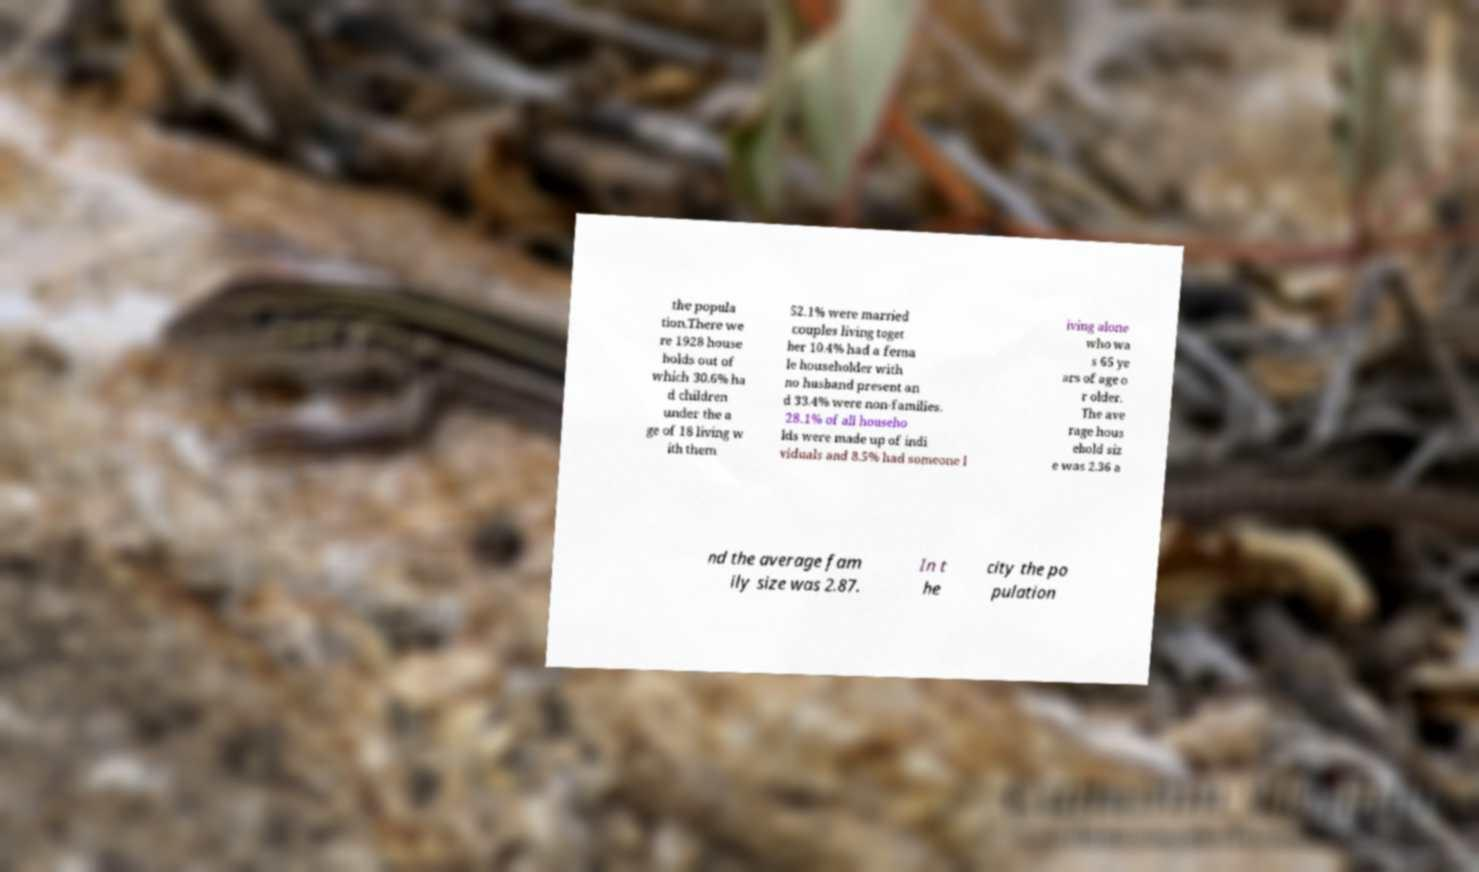What messages or text are displayed in this image? I need them in a readable, typed format. the popula tion.There we re 1928 house holds out of which 30.6% ha d children under the a ge of 18 living w ith them 52.1% were married couples living toget her 10.4% had a fema le householder with no husband present an d 33.4% were non-families. 28.1% of all househo lds were made up of indi viduals and 8.5% had someone l iving alone who wa s 65 ye ars of age o r older. The ave rage hous ehold siz e was 2.36 a nd the average fam ily size was 2.87. In t he city the po pulation 